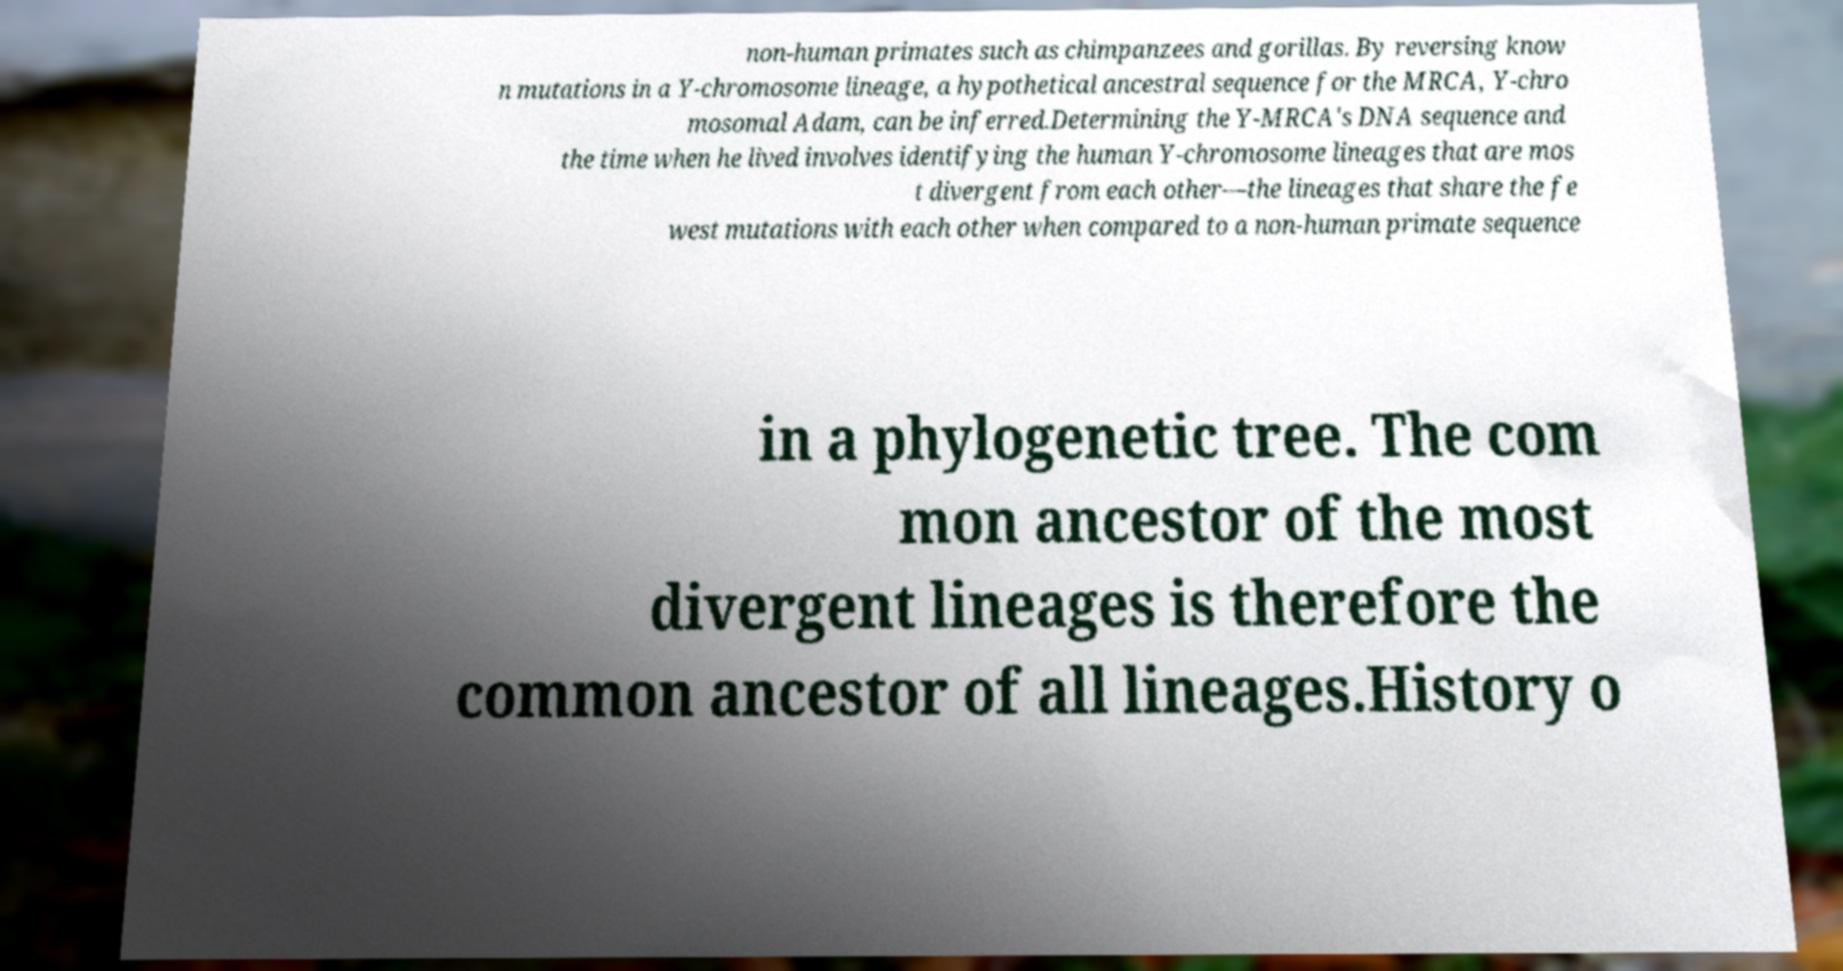What messages or text are displayed in this image? I need them in a readable, typed format. non-human primates such as chimpanzees and gorillas. By reversing know n mutations in a Y-chromosome lineage, a hypothetical ancestral sequence for the MRCA, Y-chro mosomal Adam, can be inferred.Determining the Y-MRCA's DNA sequence and the time when he lived involves identifying the human Y-chromosome lineages that are mos t divergent from each other—the lineages that share the fe west mutations with each other when compared to a non-human primate sequence in a phylogenetic tree. The com mon ancestor of the most divergent lineages is therefore the common ancestor of all lineages.History o 